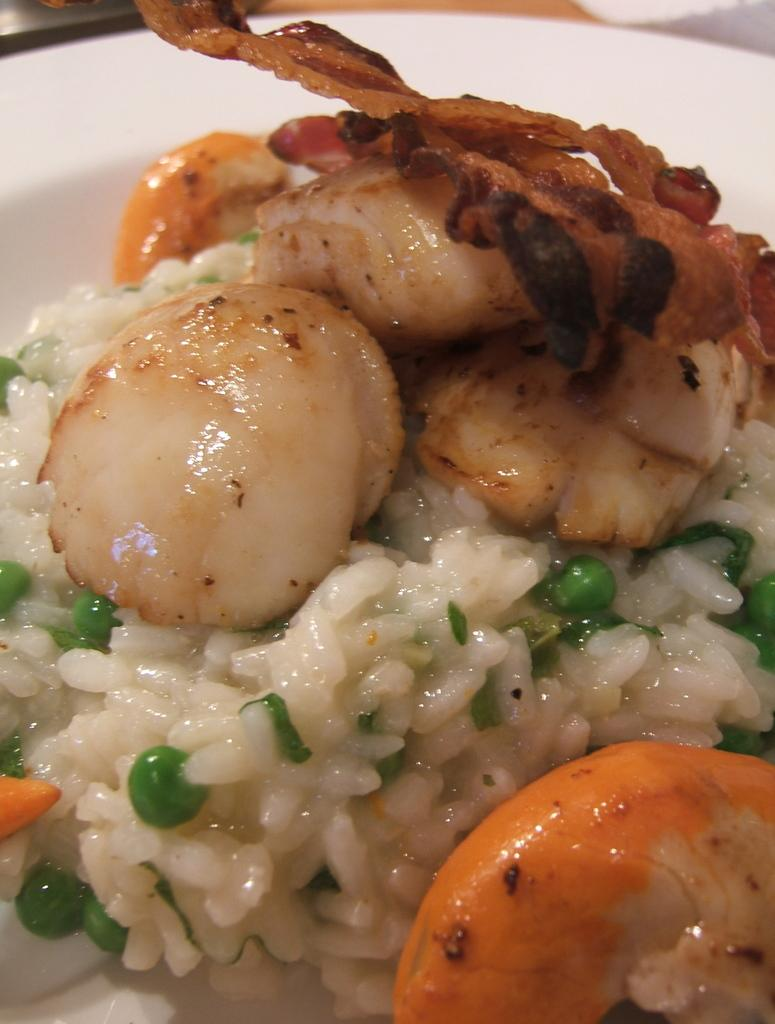What is the main subject of the image? There is a food item in the image. How is the food item presented in the image? The food item is placed on a white color plate. Can you see an airplane flying in the background of the image? There is no mention of an airplane or any background in the provided facts, so it cannot be determined if an airplane is present in the image. 